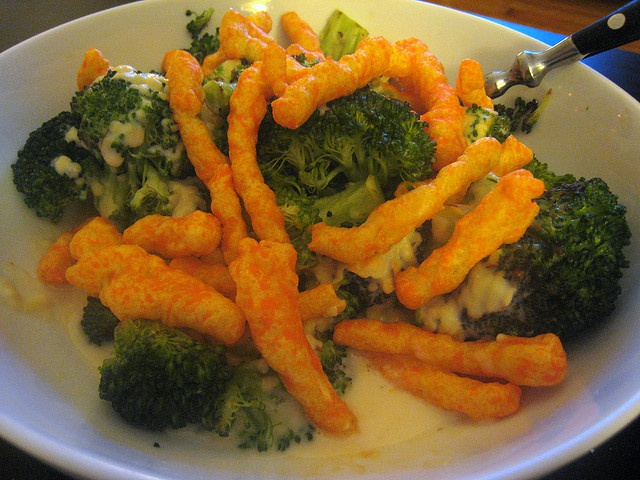Describe the objects in this image and their specific colors. I can see dining table in black, red, olive, tan, and orange tones, bowl in red, black, olive, tan, and orange tones, broccoli in gray, black, olive, and brown tones, broccoli in gray, black, darkgreen, and maroon tones, and broccoli in gray, black, darkgreen, maroon, and brown tones in this image. 